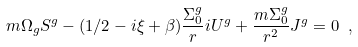<formula> <loc_0><loc_0><loc_500><loc_500>m \Omega _ { g } S ^ { g } - ( 1 / 2 - i \xi + \beta ) \frac { \Sigma _ { 0 } ^ { g } } { r } i U ^ { g } + \frac { m \Sigma _ { 0 } ^ { g } } { r ^ { 2 } } J ^ { g } = 0 \ ,</formula> 